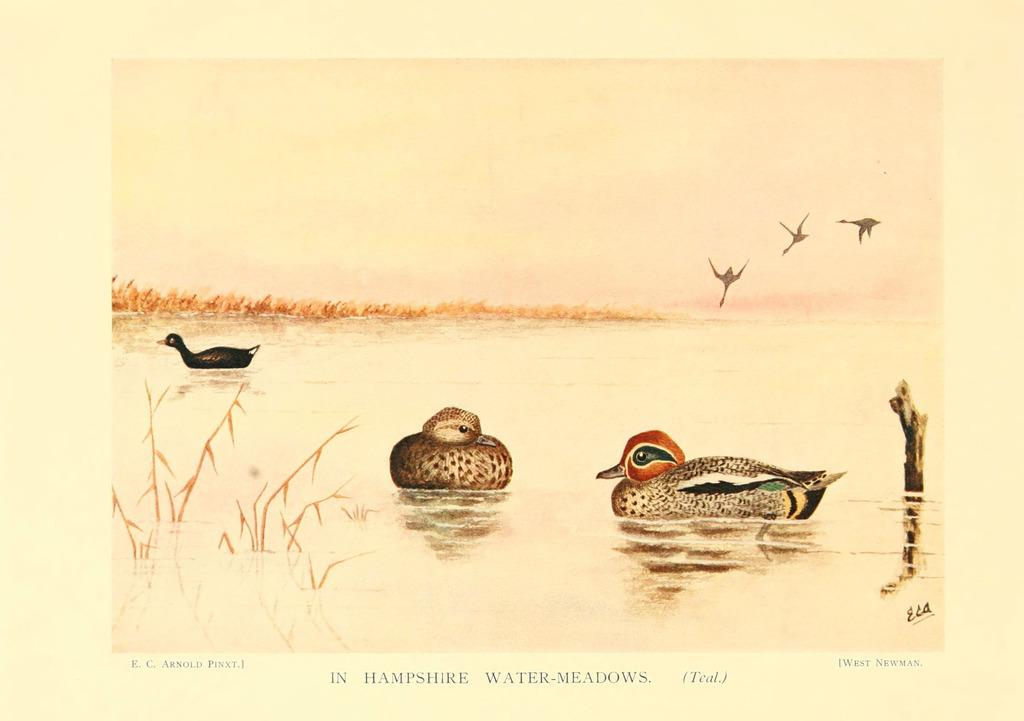What is the main object in the image? There is a paper in the image. Can you describe the paper's color? The paper is cream-colored. What is depicted on the paper? There are birds on the paper. What color are the birds? The birds are in brown color. Where are the birds depicted on the paper? The birds are depicted in water. What type of pest can be seen crawling on the paper in the image? There is no pest present on the paper in the image; it features birds depicted in water. 